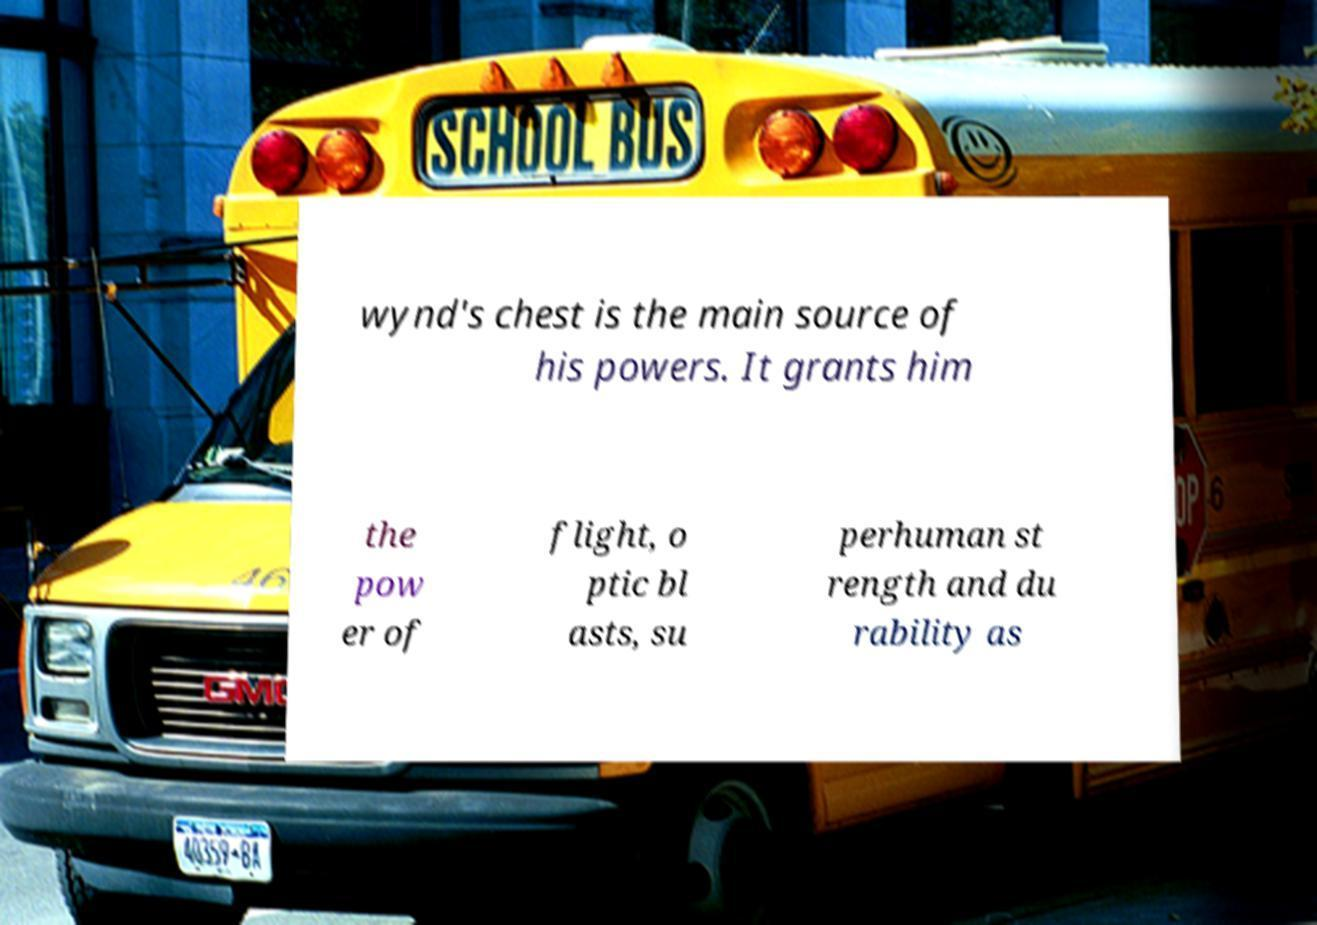Could you assist in decoding the text presented in this image and type it out clearly? wynd's chest is the main source of his powers. It grants him the pow er of flight, o ptic bl asts, su perhuman st rength and du rability as 